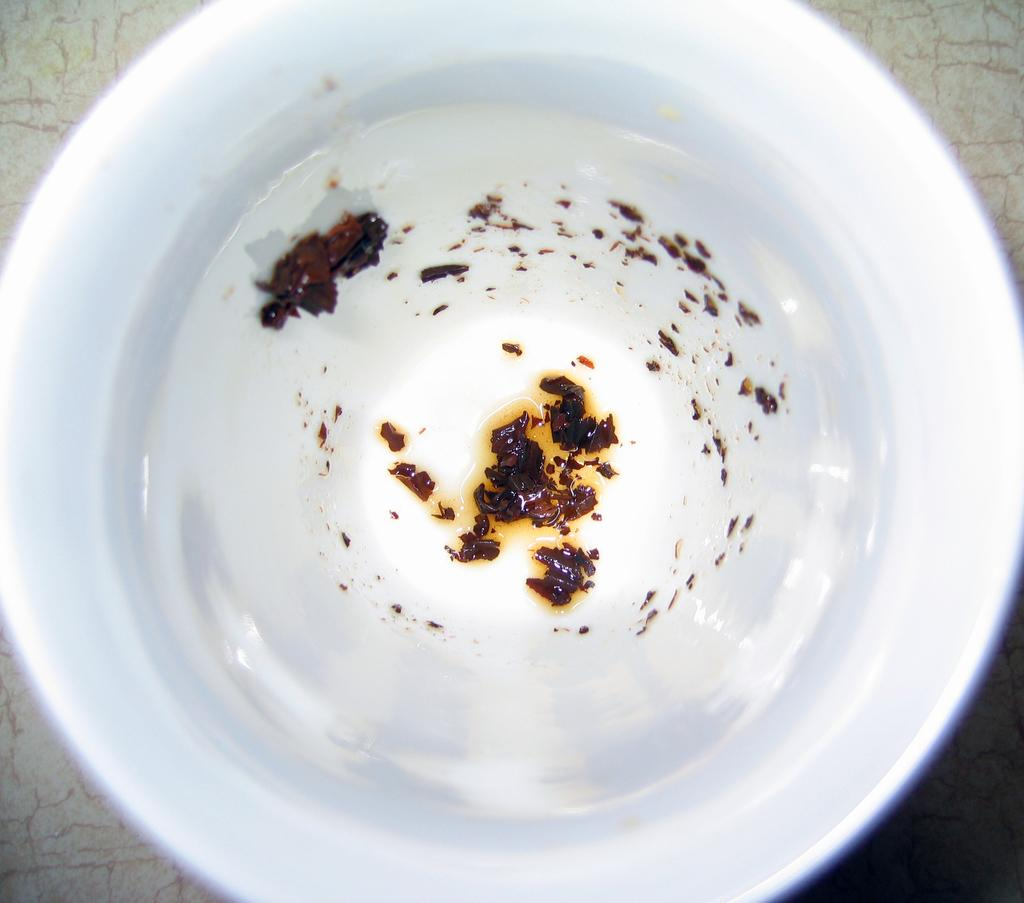What is the main object in the image? There is an object that looks like a cup in the image. What is inside the cup? The cup contains a drink. Can you describe the drink in the cup? The drink has topping. How does the doll feel about the rain in the image? There is no doll present in the image, and no mention of rain, so it is not possible to answer this question. 